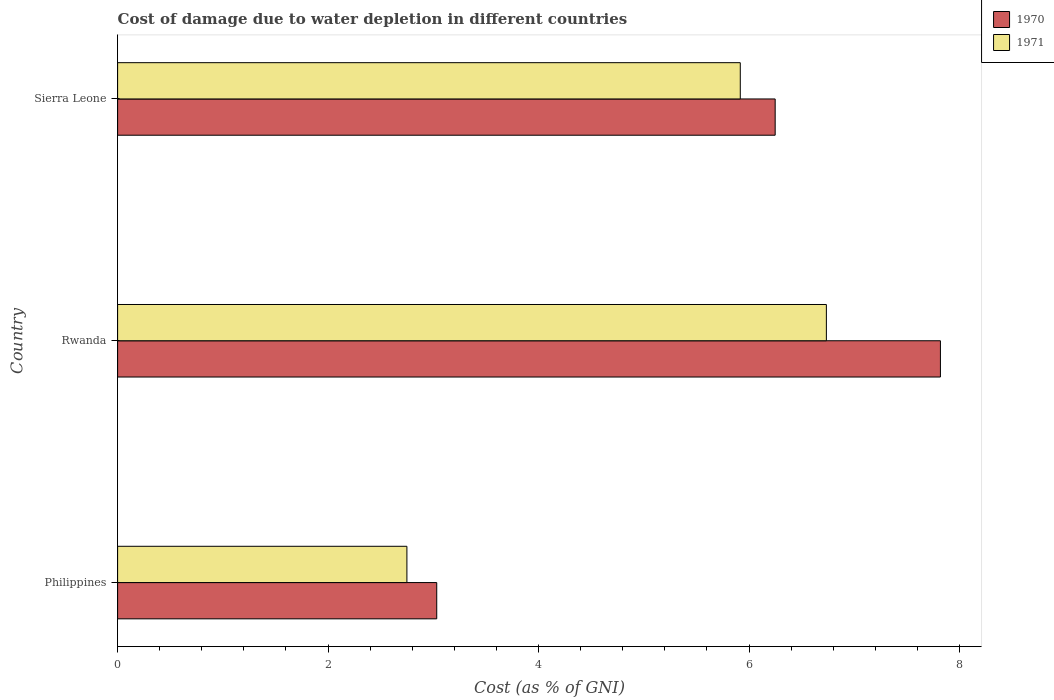How many different coloured bars are there?
Make the answer very short. 2. How many bars are there on the 2nd tick from the top?
Offer a very short reply. 2. How many bars are there on the 3rd tick from the bottom?
Offer a terse response. 2. What is the label of the 1st group of bars from the top?
Your answer should be very brief. Sierra Leone. In how many cases, is the number of bars for a given country not equal to the number of legend labels?
Your answer should be very brief. 0. What is the cost of damage caused due to water depletion in 1970 in Rwanda?
Ensure brevity in your answer.  7.82. Across all countries, what is the maximum cost of damage caused due to water depletion in 1971?
Your answer should be very brief. 6.73. Across all countries, what is the minimum cost of damage caused due to water depletion in 1970?
Your answer should be very brief. 3.03. In which country was the cost of damage caused due to water depletion in 1971 maximum?
Keep it short and to the point. Rwanda. What is the total cost of damage caused due to water depletion in 1970 in the graph?
Give a very brief answer. 17.1. What is the difference between the cost of damage caused due to water depletion in 1971 in Philippines and that in Sierra Leone?
Your answer should be very brief. -3.17. What is the difference between the cost of damage caused due to water depletion in 1970 in Sierra Leone and the cost of damage caused due to water depletion in 1971 in Philippines?
Ensure brevity in your answer.  3.5. What is the average cost of damage caused due to water depletion in 1971 per country?
Make the answer very short. 5.13. What is the difference between the cost of damage caused due to water depletion in 1970 and cost of damage caused due to water depletion in 1971 in Sierra Leone?
Provide a short and direct response. 0.33. What is the ratio of the cost of damage caused due to water depletion in 1970 in Philippines to that in Sierra Leone?
Offer a very short reply. 0.49. What is the difference between the highest and the second highest cost of damage caused due to water depletion in 1970?
Offer a terse response. 1.57. What is the difference between the highest and the lowest cost of damage caused due to water depletion in 1970?
Make the answer very short. 4.79. What does the 1st bar from the bottom in Rwanda represents?
Ensure brevity in your answer.  1970. How many bars are there?
Your answer should be compact. 6. Are all the bars in the graph horizontal?
Keep it short and to the point. Yes. Where does the legend appear in the graph?
Ensure brevity in your answer.  Top right. How many legend labels are there?
Provide a short and direct response. 2. How are the legend labels stacked?
Ensure brevity in your answer.  Vertical. What is the title of the graph?
Keep it short and to the point. Cost of damage due to water depletion in different countries. What is the label or title of the X-axis?
Offer a terse response. Cost (as % of GNI). What is the label or title of the Y-axis?
Make the answer very short. Country. What is the Cost (as % of GNI) of 1970 in Philippines?
Ensure brevity in your answer.  3.03. What is the Cost (as % of GNI) of 1971 in Philippines?
Give a very brief answer. 2.75. What is the Cost (as % of GNI) in 1970 in Rwanda?
Give a very brief answer. 7.82. What is the Cost (as % of GNI) in 1971 in Rwanda?
Ensure brevity in your answer.  6.73. What is the Cost (as % of GNI) in 1970 in Sierra Leone?
Your answer should be compact. 6.25. What is the Cost (as % of GNI) in 1971 in Sierra Leone?
Offer a terse response. 5.92. Across all countries, what is the maximum Cost (as % of GNI) of 1970?
Make the answer very short. 7.82. Across all countries, what is the maximum Cost (as % of GNI) in 1971?
Give a very brief answer. 6.73. Across all countries, what is the minimum Cost (as % of GNI) in 1970?
Ensure brevity in your answer.  3.03. Across all countries, what is the minimum Cost (as % of GNI) of 1971?
Your answer should be very brief. 2.75. What is the total Cost (as % of GNI) of 1970 in the graph?
Your answer should be very brief. 17.1. What is the total Cost (as % of GNI) in 1971 in the graph?
Your answer should be very brief. 15.4. What is the difference between the Cost (as % of GNI) of 1970 in Philippines and that in Rwanda?
Provide a succinct answer. -4.79. What is the difference between the Cost (as % of GNI) in 1971 in Philippines and that in Rwanda?
Make the answer very short. -3.99. What is the difference between the Cost (as % of GNI) of 1970 in Philippines and that in Sierra Leone?
Keep it short and to the point. -3.22. What is the difference between the Cost (as % of GNI) in 1971 in Philippines and that in Sierra Leone?
Offer a very short reply. -3.17. What is the difference between the Cost (as % of GNI) of 1970 in Rwanda and that in Sierra Leone?
Offer a terse response. 1.57. What is the difference between the Cost (as % of GNI) in 1971 in Rwanda and that in Sierra Leone?
Your response must be concise. 0.82. What is the difference between the Cost (as % of GNI) of 1970 in Philippines and the Cost (as % of GNI) of 1971 in Rwanda?
Give a very brief answer. -3.7. What is the difference between the Cost (as % of GNI) in 1970 in Philippines and the Cost (as % of GNI) in 1971 in Sierra Leone?
Give a very brief answer. -2.88. What is the difference between the Cost (as % of GNI) of 1970 in Rwanda and the Cost (as % of GNI) of 1971 in Sierra Leone?
Your answer should be compact. 1.9. What is the average Cost (as % of GNI) in 1970 per country?
Ensure brevity in your answer.  5.7. What is the average Cost (as % of GNI) in 1971 per country?
Make the answer very short. 5.13. What is the difference between the Cost (as % of GNI) of 1970 and Cost (as % of GNI) of 1971 in Philippines?
Keep it short and to the point. 0.28. What is the difference between the Cost (as % of GNI) in 1970 and Cost (as % of GNI) in 1971 in Rwanda?
Make the answer very short. 1.08. What is the difference between the Cost (as % of GNI) of 1970 and Cost (as % of GNI) of 1971 in Sierra Leone?
Your answer should be very brief. 0.33. What is the ratio of the Cost (as % of GNI) of 1970 in Philippines to that in Rwanda?
Provide a short and direct response. 0.39. What is the ratio of the Cost (as % of GNI) of 1971 in Philippines to that in Rwanda?
Keep it short and to the point. 0.41. What is the ratio of the Cost (as % of GNI) of 1970 in Philippines to that in Sierra Leone?
Your answer should be compact. 0.49. What is the ratio of the Cost (as % of GNI) in 1971 in Philippines to that in Sierra Leone?
Provide a succinct answer. 0.46. What is the ratio of the Cost (as % of GNI) in 1970 in Rwanda to that in Sierra Leone?
Offer a terse response. 1.25. What is the ratio of the Cost (as % of GNI) in 1971 in Rwanda to that in Sierra Leone?
Keep it short and to the point. 1.14. What is the difference between the highest and the second highest Cost (as % of GNI) of 1970?
Give a very brief answer. 1.57. What is the difference between the highest and the second highest Cost (as % of GNI) of 1971?
Provide a short and direct response. 0.82. What is the difference between the highest and the lowest Cost (as % of GNI) of 1970?
Your response must be concise. 4.79. What is the difference between the highest and the lowest Cost (as % of GNI) in 1971?
Offer a very short reply. 3.99. 